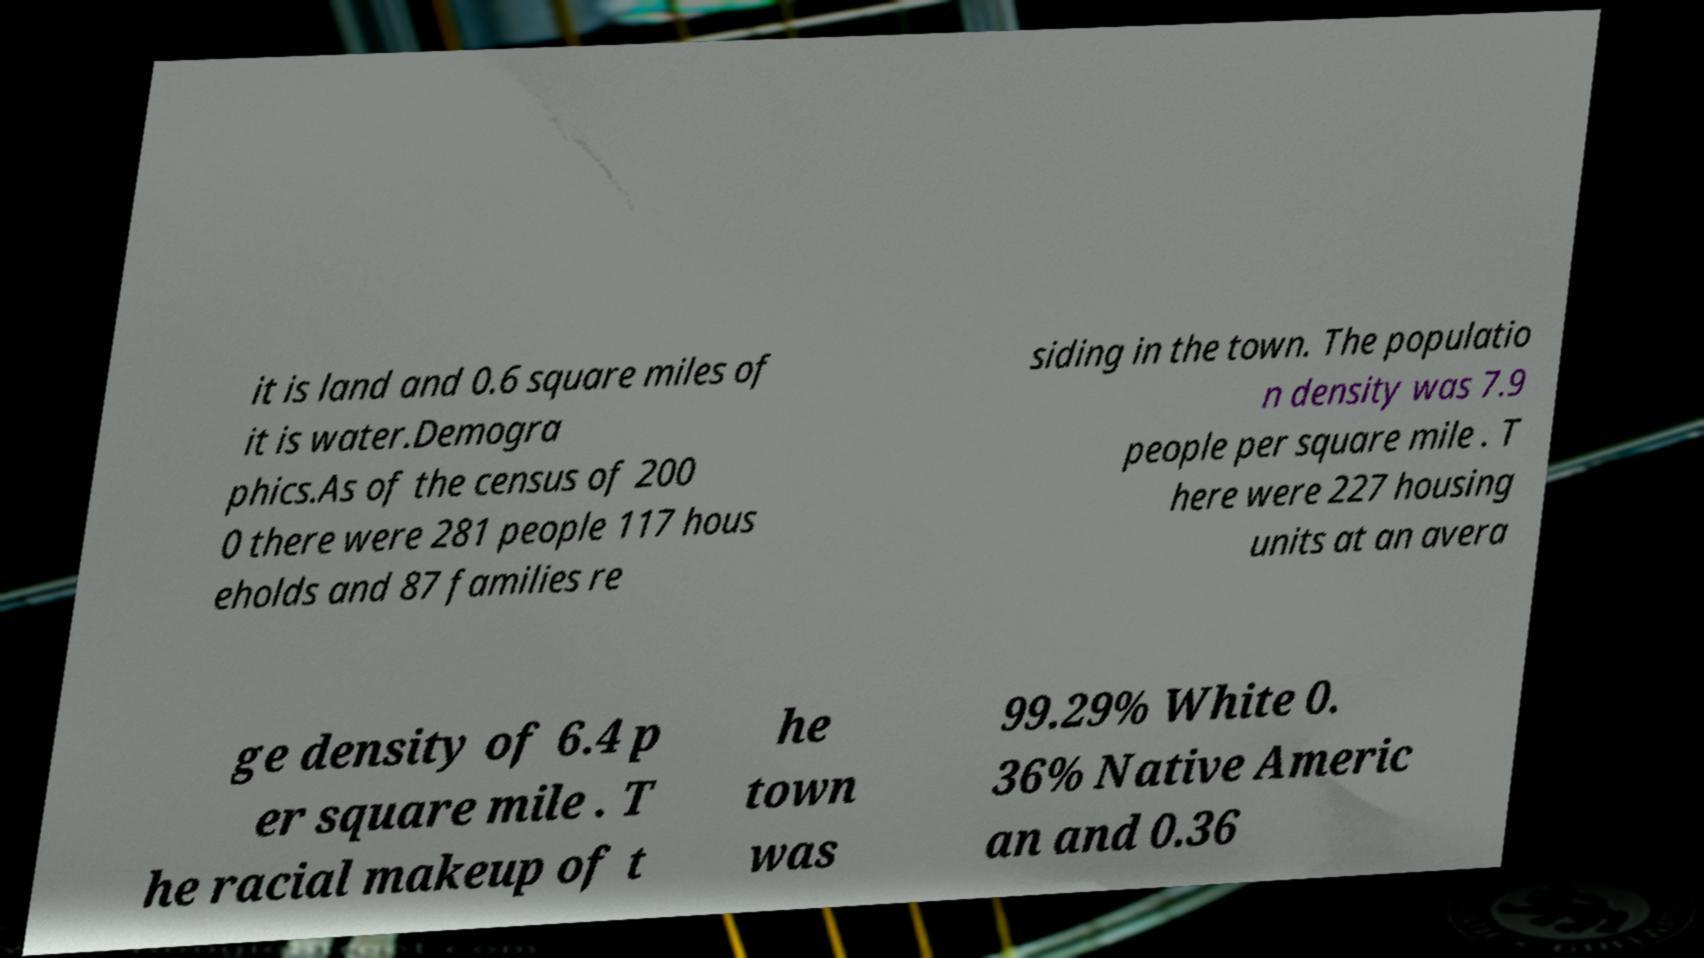For documentation purposes, I need the text within this image transcribed. Could you provide that? it is land and 0.6 square miles of it is water.Demogra phics.As of the census of 200 0 there were 281 people 117 hous eholds and 87 families re siding in the town. The populatio n density was 7.9 people per square mile . T here were 227 housing units at an avera ge density of 6.4 p er square mile . T he racial makeup of t he town was 99.29% White 0. 36% Native Americ an and 0.36 